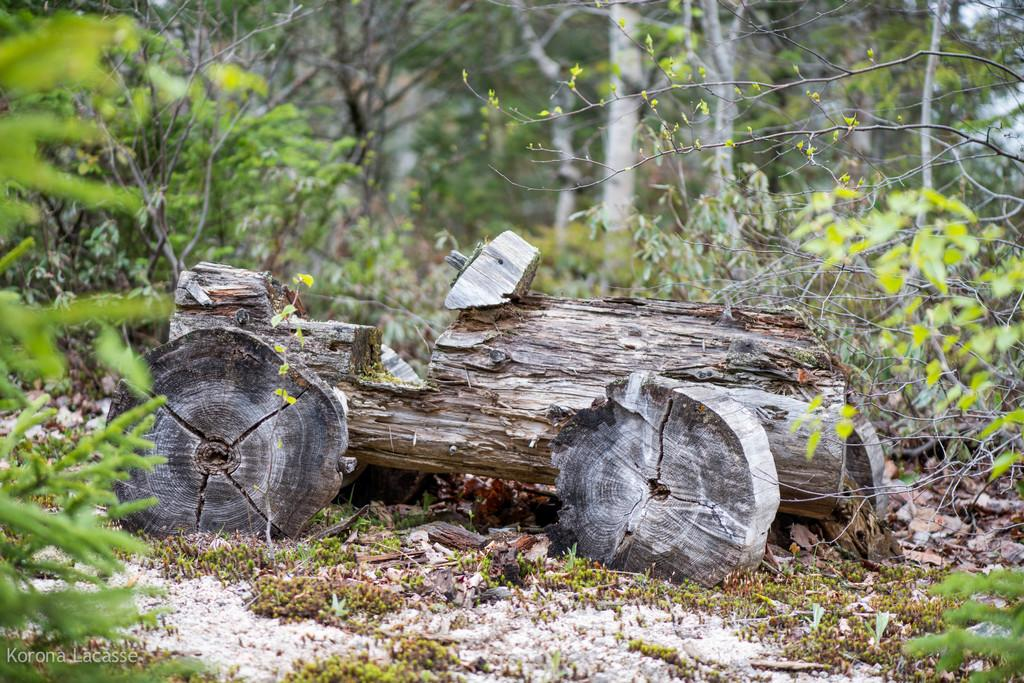What is the main object in the image? There is a trunk in the image. What can be seen around the trunk? There are green color trees around the trunk. Where is the school located in the image? There is no school present in the image; it only features a trunk and green color trees. What type of alley can be seen in the image? There is no alley present in the image; it only features a trunk and green color trees. 